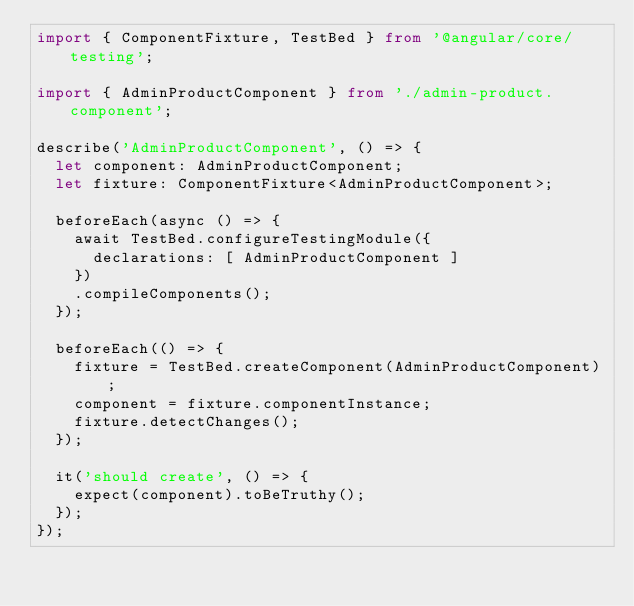<code> <loc_0><loc_0><loc_500><loc_500><_TypeScript_>import { ComponentFixture, TestBed } from '@angular/core/testing';

import { AdminProductComponent } from './admin-product.component';

describe('AdminProductComponent', () => {
  let component: AdminProductComponent;
  let fixture: ComponentFixture<AdminProductComponent>;

  beforeEach(async () => {
    await TestBed.configureTestingModule({
      declarations: [ AdminProductComponent ]
    })
    .compileComponents();
  });

  beforeEach(() => {
    fixture = TestBed.createComponent(AdminProductComponent);
    component = fixture.componentInstance;
    fixture.detectChanges();
  });

  it('should create', () => {
    expect(component).toBeTruthy();
  });
});
</code> 